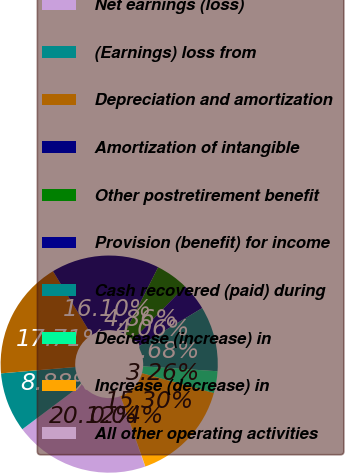Convert chart to OTSL. <chart><loc_0><loc_0><loc_500><loc_500><pie_chart><fcel>Net earnings (loss)<fcel>(Earnings) loss from<fcel>Depreciation and amortization<fcel>Amortization of intangible<fcel>Other postretirement benefit<fcel>Provision (benefit) for income<fcel>Cash recovered (paid) during<fcel>Decrease (increase) in<fcel>Increase (decrease) in<fcel>All other operating activities<nl><fcel>20.12%<fcel>8.88%<fcel>17.71%<fcel>16.1%<fcel>4.86%<fcel>4.06%<fcel>9.68%<fcel>3.26%<fcel>15.3%<fcel>0.04%<nl></chart> 